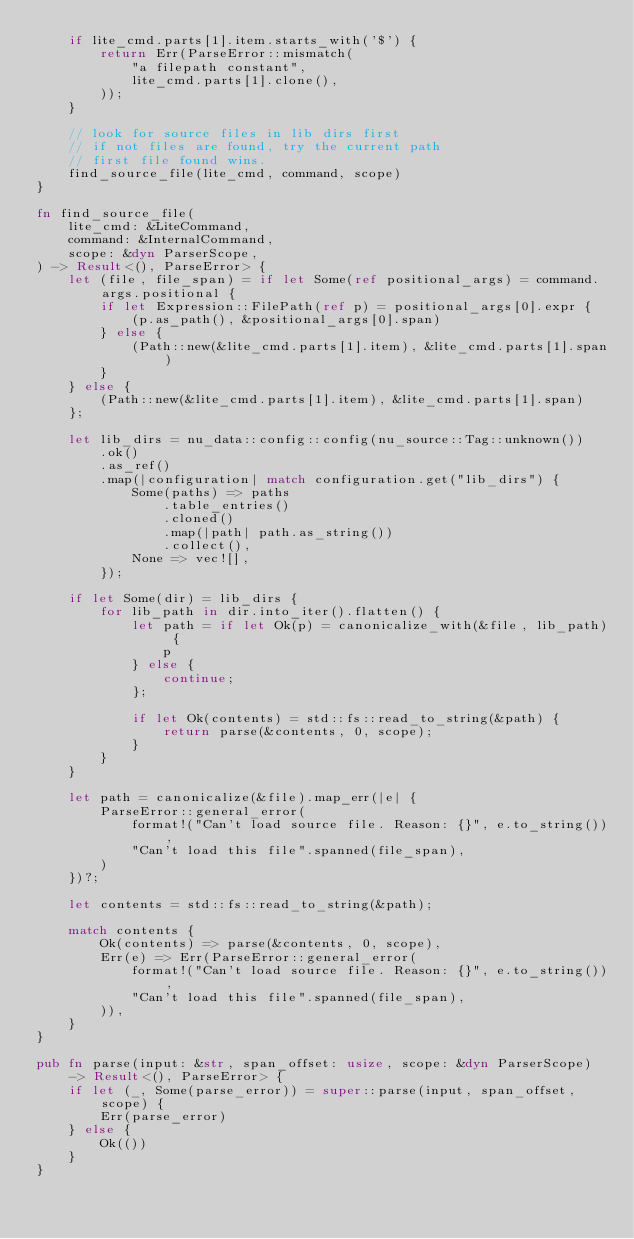Convert code to text. <code><loc_0><loc_0><loc_500><loc_500><_Rust_>    if lite_cmd.parts[1].item.starts_with('$') {
        return Err(ParseError::mismatch(
            "a filepath constant",
            lite_cmd.parts[1].clone(),
        ));
    }

    // look for source files in lib dirs first
    // if not files are found, try the current path
    // first file found wins.
    find_source_file(lite_cmd, command, scope)
}

fn find_source_file(
    lite_cmd: &LiteCommand,
    command: &InternalCommand,
    scope: &dyn ParserScope,
) -> Result<(), ParseError> {
    let (file, file_span) = if let Some(ref positional_args) = command.args.positional {
        if let Expression::FilePath(ref p) = positional_args[0].expr {
            (p.as_path(), &positional_args[0].span)
        } else {
            (Path::new(&lite_cmd.parts[1].item), &lite_cmd.parts[1].span)
        }
    } else {
        (Path::new(&lite_cmd.parts[1].item), &lite_cmd.parts[1].span)
    };

    let lib_dirs = nu_data::config::config(nu_source::Tag::unknown())
        .ok()
        .as_ref()
        .map(|configuration| match configuration.get("lib_dirs") {
            Some(paths) => paths
                .table_entries()
                .cloned()
                .map(|path| path.as_string())
                .collect(),
            None => vec![],
        });

    if let Some(dir) = lib_dirs {
        for lib_path in dir.into_iter().flatten() {
            let path = if let Ok(p) = canonicalize_with(&file, lib_path) {
                p
            } else {
                continue;
            };

            if let Ok(contents) = std::fs::read_to_string(&path) {
                return parse(&contents, 0, scope);
            }
        }
    }

    let path = canonicalize(&file).map_err(|e| {
        ParseError::general_error(
            format!("Can't load source file. Reason: {}", e.to_string()),
            "Can't load this file".spanned(file_span),
        )
    })?;

    let contents = std::fs::read_to_string(&path);

    match contents {
        Ok(contents) => parse(&contents, 0, scope),
        Err(e) => Err(ParseError::general_error(
            format!("Can't load source file. Reason: {}", e.to_string()),
            "Can't load this file".spanned(file_span),
        )),
    }
}

pub fn parse(input: &str, span_offset: usize, scope: &dyn ParserScope) -> Result<(), ParseError> {
    if let (_, Some(parse_error)) = super::parse(input, span_offset, scope) {
        Err(parse_error)
    } else {
        Ok(())
    }
}
</code> 